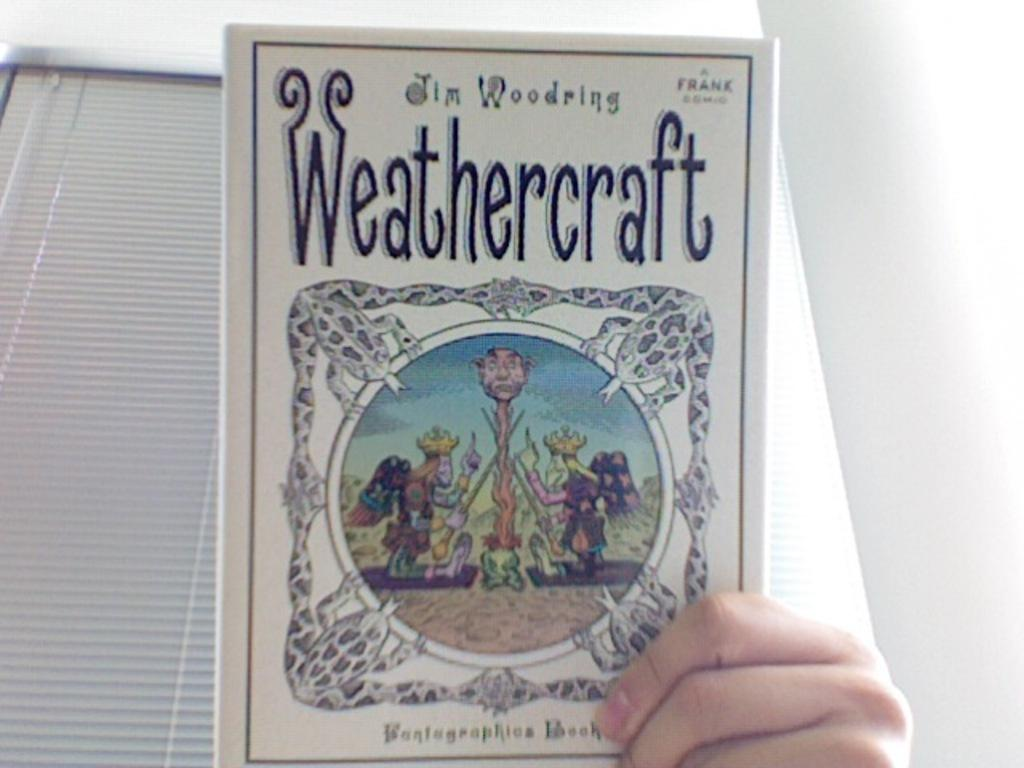<image>
Summarize the visual content of the image. A person holding a book titled Weathercraft by Jim Woodring. 